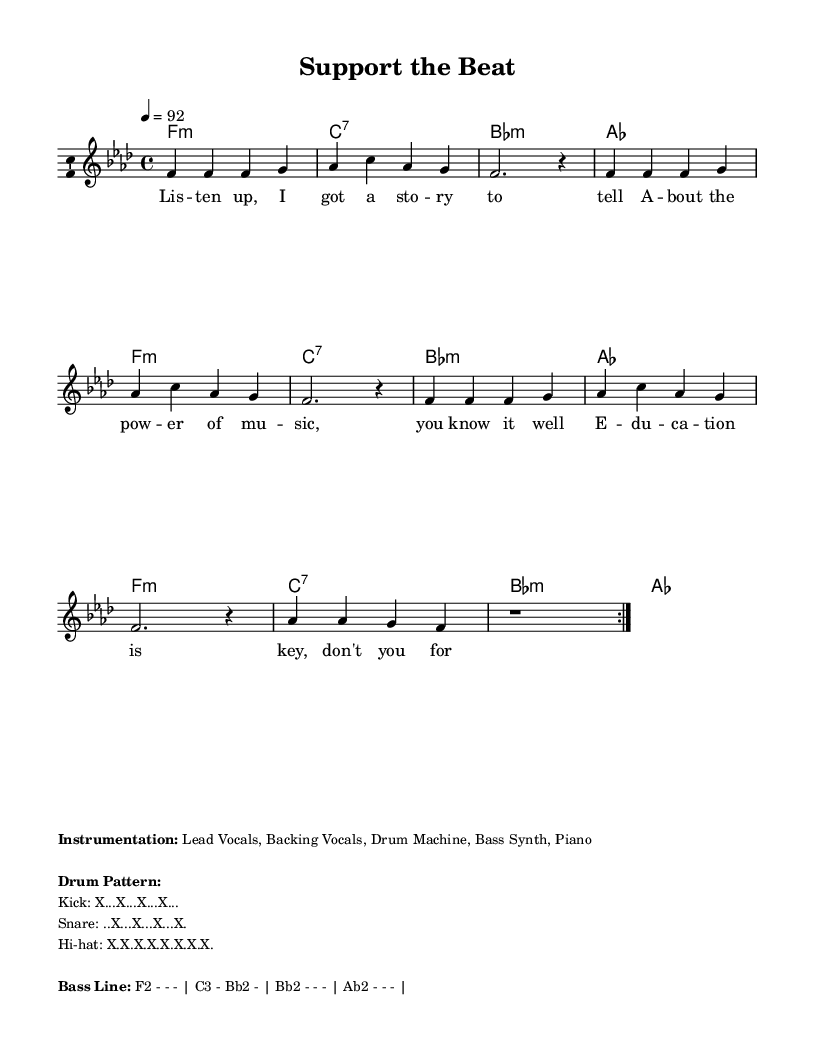What is the key signature of this music? The key signature indicated in the music sheet is F minor, which has four flats: B, E, A, and D.
Answer: F minor What is the time signature of this music? The time signature shown at the beginning of the music is 4/4, meaning there are four beats per measure and the quarter note receives one beat.
Answer: 4/4 What is the tempo marking for this piece? The tempo marking specifies a speed of quarter note equals 92 beats per minute. This indicates the piece should be played moderately fast.
Answer: 92 How many measures are repeated in the melody? The melody section contains a repeat indication, showing that the previous measures should be played twice before moving on, making it a total of eight measures played.
Answer: 8 measures What is the primary theme of the lyrics? The lyrics emphasize the importance of music education and advocate for supporting local music stores, which aligns with community and educational values in music.
Answer: Importance of music education What instruments are listed in the instrumentation? The marked instrumentation includes Lead Vocals, Backing Vocals, Drum Machine, Bass Synth, and Piano, identifying the main components of the instrumental arrangement.
Answer: Lead Vocals, Backing Vocals, Drum Machine, Bass Synth, Piano What type of musical form can be inferred from the structure? The music appears to have a verse structure as indicated by repeated melodic phrases, typical in Hip Hop songs, which often focus on lyrical storytelling.
Answer: Verse structure 